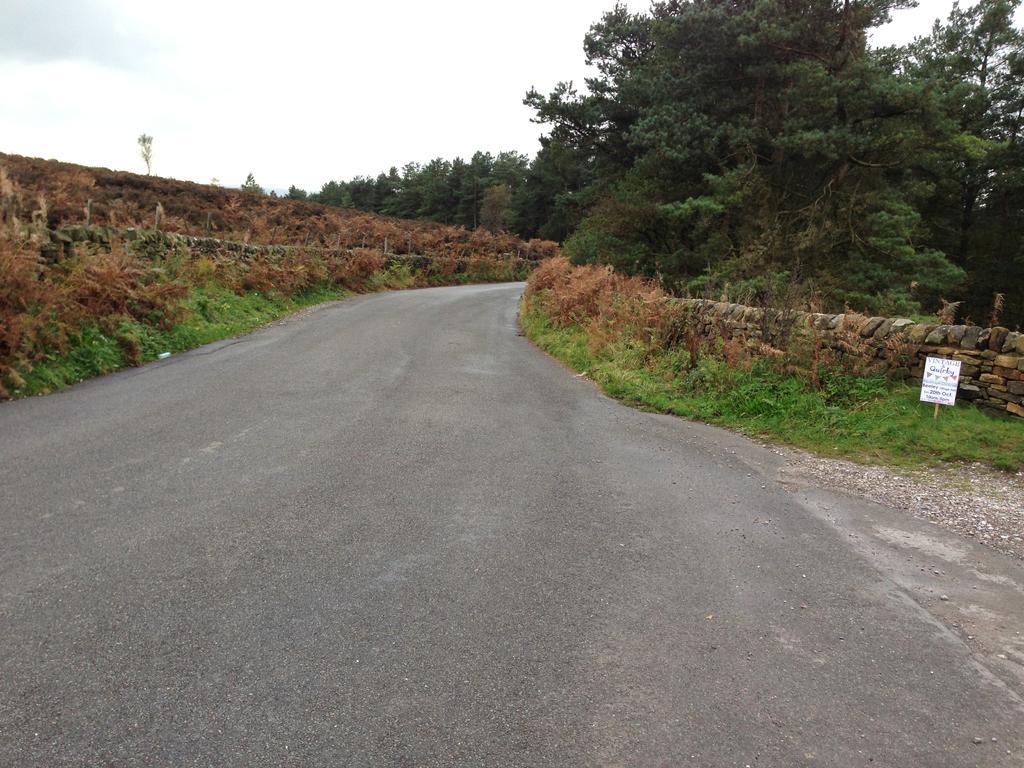Can you describe this image briefly? In this picture we can see the road. On the right and left side we can see the small stones, plants and grass. In the background we can see many trees. On the right there is a board. At the top we can see sky and clouds. 